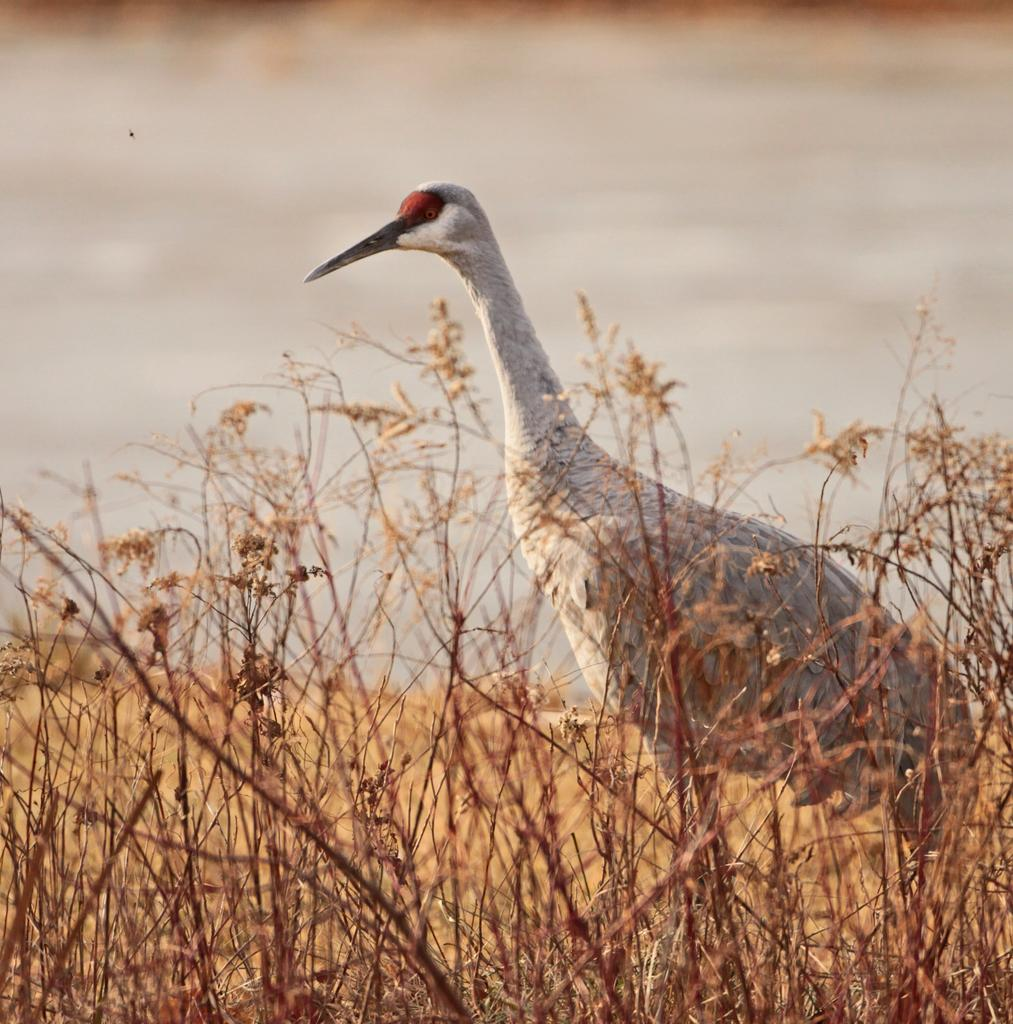What type of animal can be seen in the image? There is a bird in the image. What type of vegetation is present in the image? There is dry grass in the image. What natural element is visible in the image? Water is visible in the image. How would you describe the background of the image? The background of the image is blurred. What type of pie is being served on the pan in the image? There is no pie or pan present in the image. How is the soap being used in the image? There is no soap present in the image. 